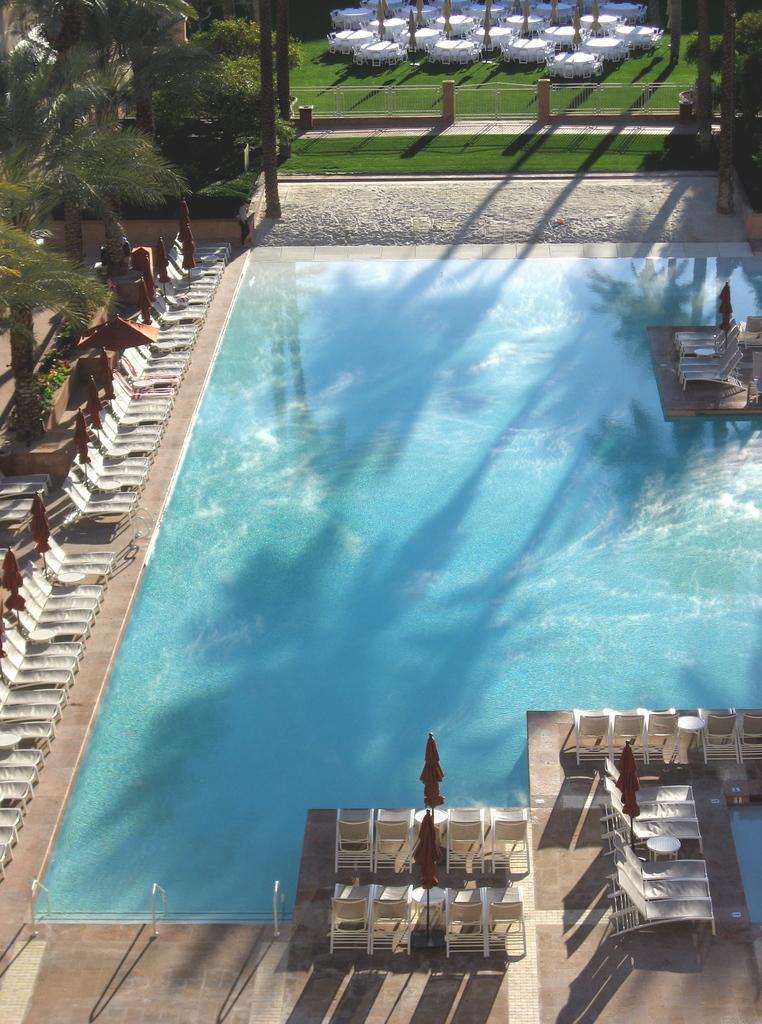In one or two sentences, can you explain what this image depicts? In this image I can see the water. In the background I can see few trees in green color and I can also see few objects in white color. 